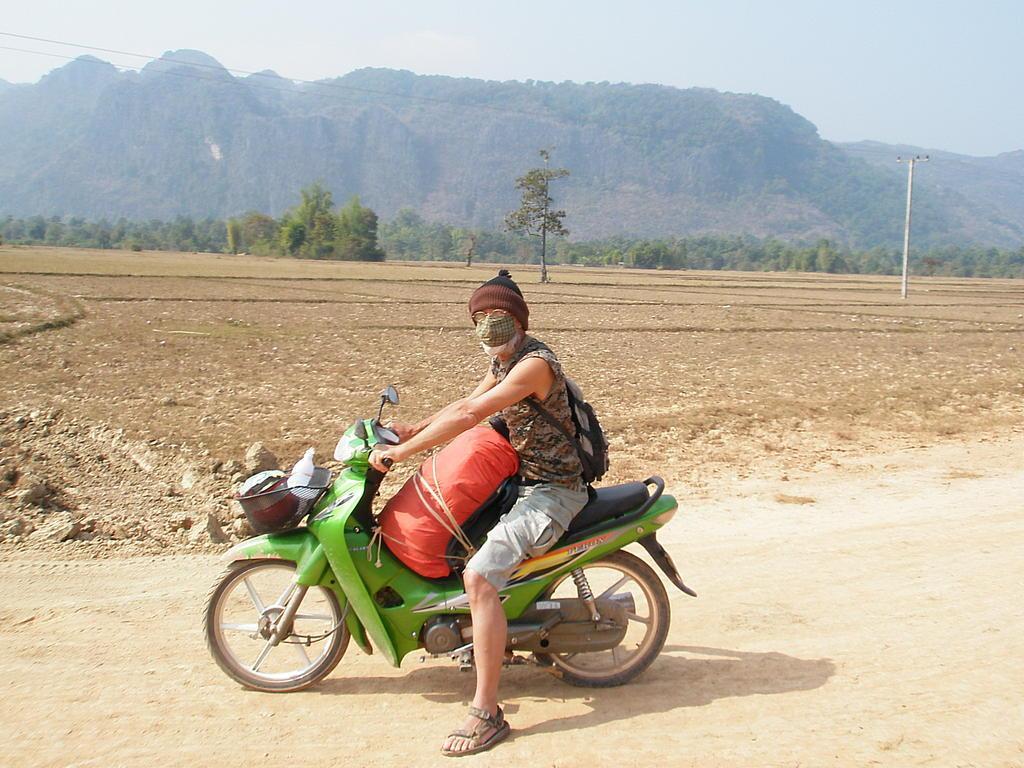Who or what is in the image? There is a person in the image. What is the person sitting on? The person is sitting on a green bike. What is in front of the person? There is luggage in front of the person. What can be seen in the background of the image? There are trees and a mountain visible in the image. What type of clam can be seen climbing the mountain in the image? There are no clams present in the image, and therefore no such activity can be observed. How many chickens are visible in the image? There are no chickens present in the image. 